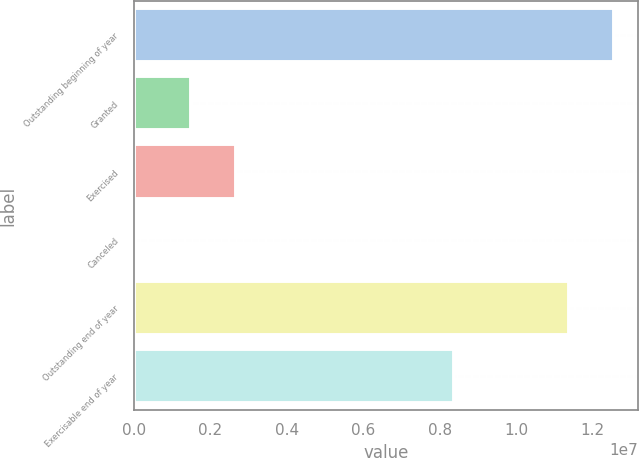Convert chart. <chart><loc_0><loc_0><loc_500><loc_500><bar_chart><fcel>Outstanding beginning of year<fcel>Granted<fcel>Exercised<fcel>Canceled<fcel>Outstanding end of year<fcel>Exercisable end of year<nl><fcel>1.2564e+07<fcel>1.49189e+06<fcel>2.6759e+06<fcel>70461<fcel>1.138e+07<fcel>8.37181e+06<nl></chart> 